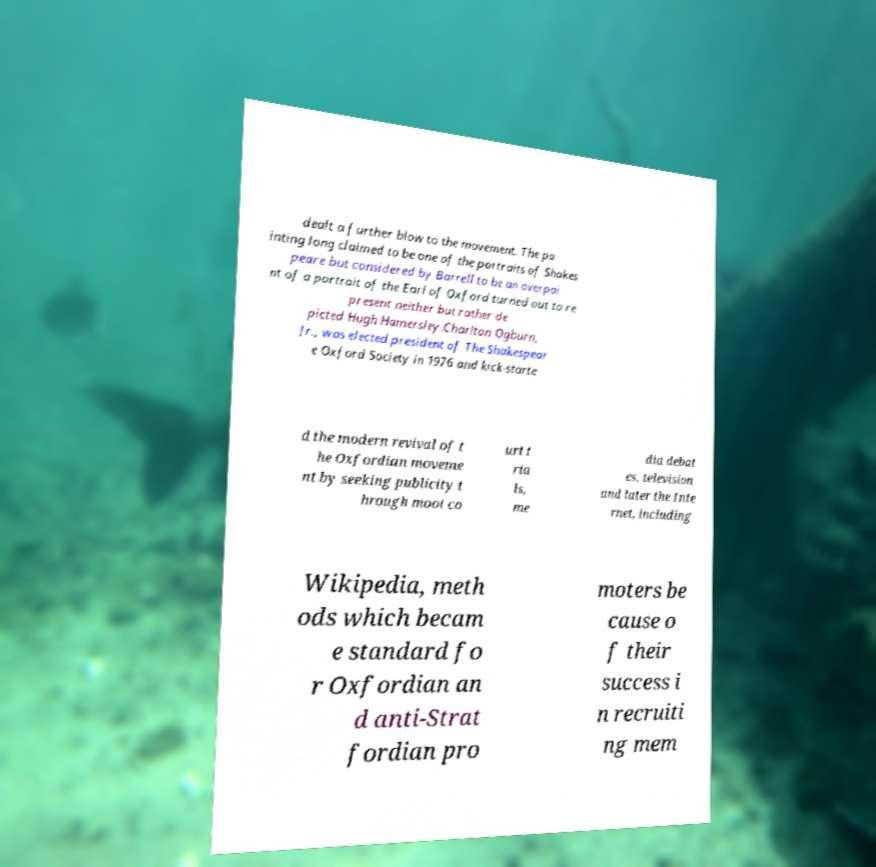Could you extract and type out the text from this image? dealt a further blow to the movement. The pa inting long claimed to be one of the portraits of Shakes peare but considered by Barrell to be an overpai nt of a portrait of the Earl of Oxford turned out to re present neither but rather de picted Hugh Hamersley.Charlton Ogburn, Jr., was elected president of The Shakespear e Oxford Society in 1976 and kick-starte d the modern revival of t he Oxfordian moveme nt by seeking publicity t hrough moot co urt t ria ls, me dia debat es, television and later the Inte rnet, including Wikipedia, meth ods which becam e standard fo r Oxfordian an d anti-Strat fordian pro moters be cause o f their success i n recruiti ng mem 